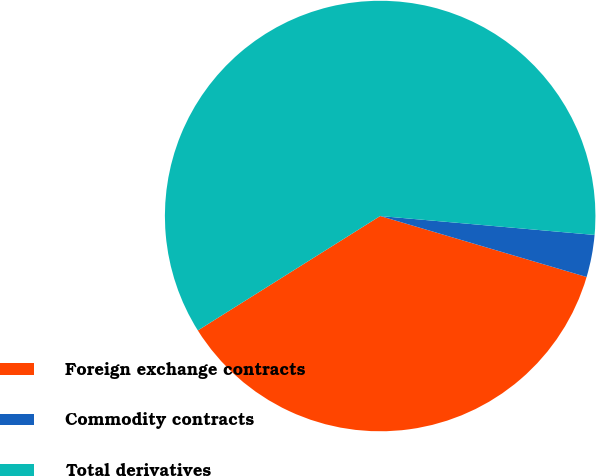Convert chart. <chart><loc_0><loc_0><loc_500><loc_500><pie_chart><fcel>Foreign exchange contracts<fcel>Commodity contracts<fcel>Total derivatives<nl><fcel>36.51%<fcel>3.17%<fcel>60.32%<nl></chart> 